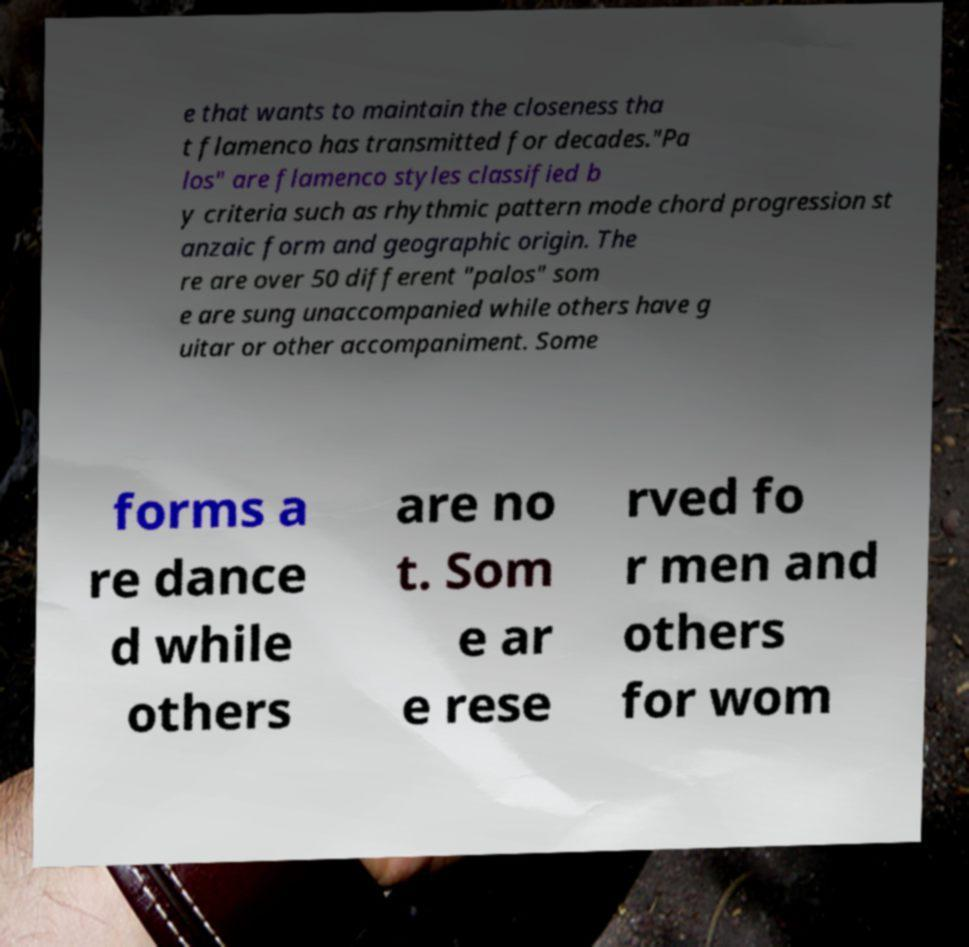There's text embedded in this image that I need extracted. Can you transcribe it verbatim? e that wants to maintain the closeness tha t flamenco has transmitted for decades."Pa los" are flamenco styles classified b y criteria such as rhythmic pattern mode chord progression st anzaic form and geographic origin. The re are over 50 different "palos" som e are sung unaccompanied while others have g uitar or other accompaniment. Some forms a re dance d while others are no t. Som e ar e rese rved fo r men and others for wom 